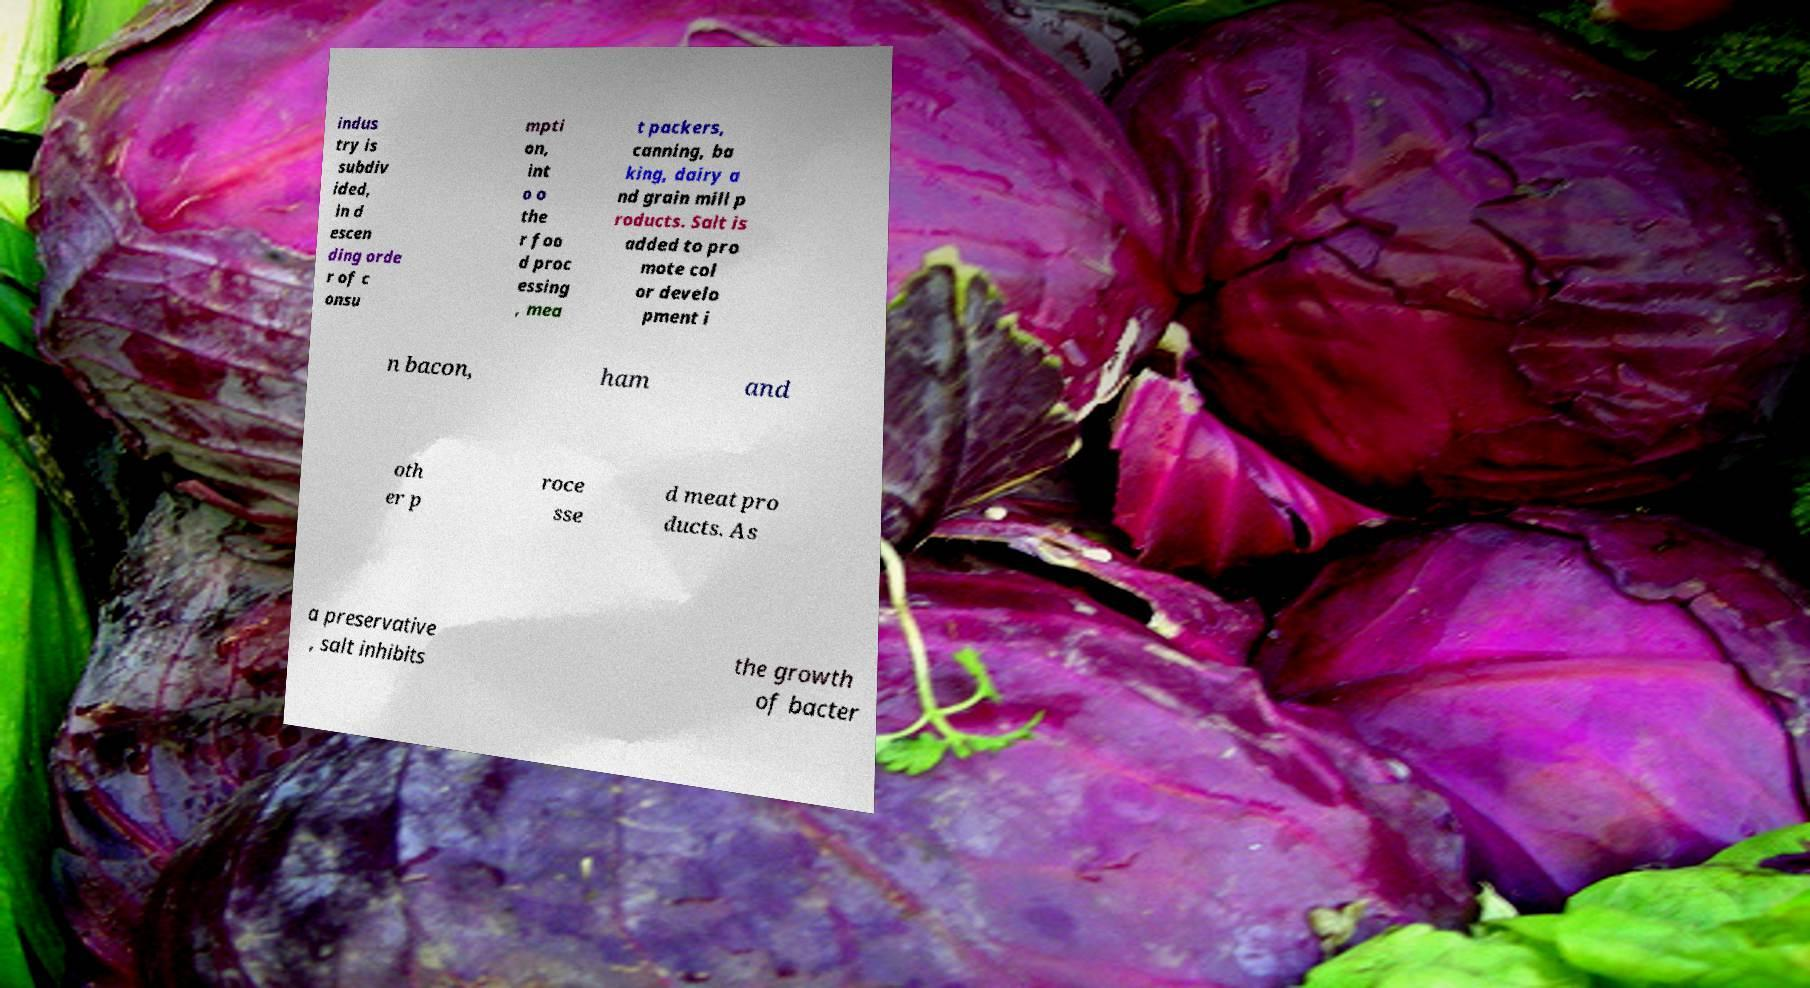There's text embedded in this image that I need extracted. Can you transcribe it verbatim? indus try is subdiv ided, in d escen ding orde r of c onsu mpti on, int o o the r foo d proc essing , mea t packers, canning, ba king, dairy a nd grain mill p roducts. Salt is added to pro mote col or develo pment i n bacon, ham and oth er p roce sse d meat pro ducts. As a preservative , salt inhibits the growth of bacter 